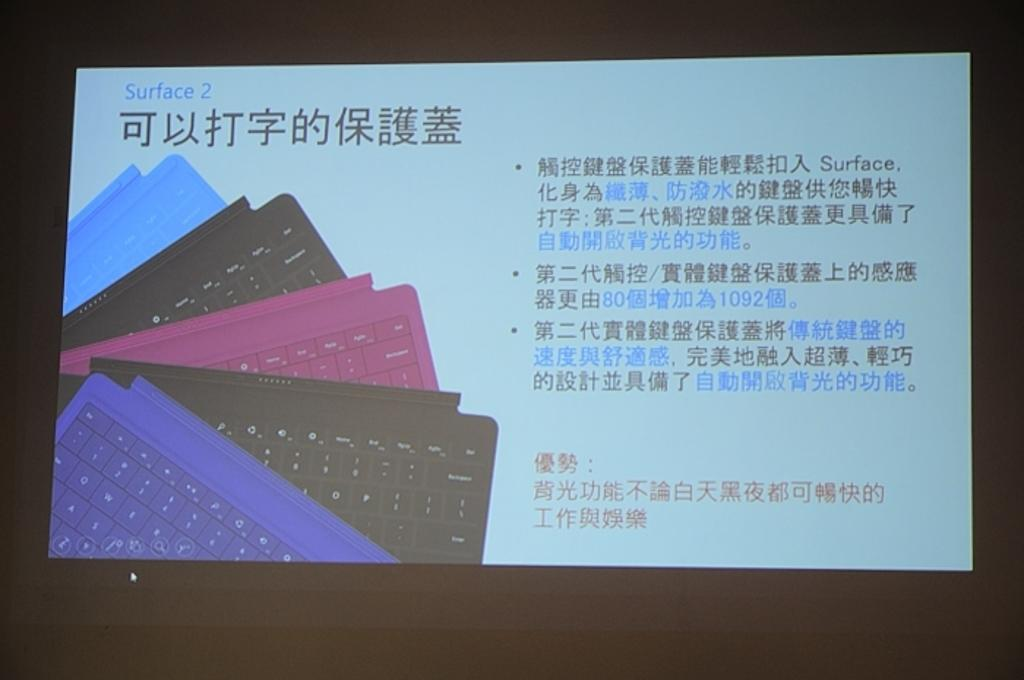<image>
Summarize the visual content of the image. Computer screen showing chinese words and says Surface 2. 